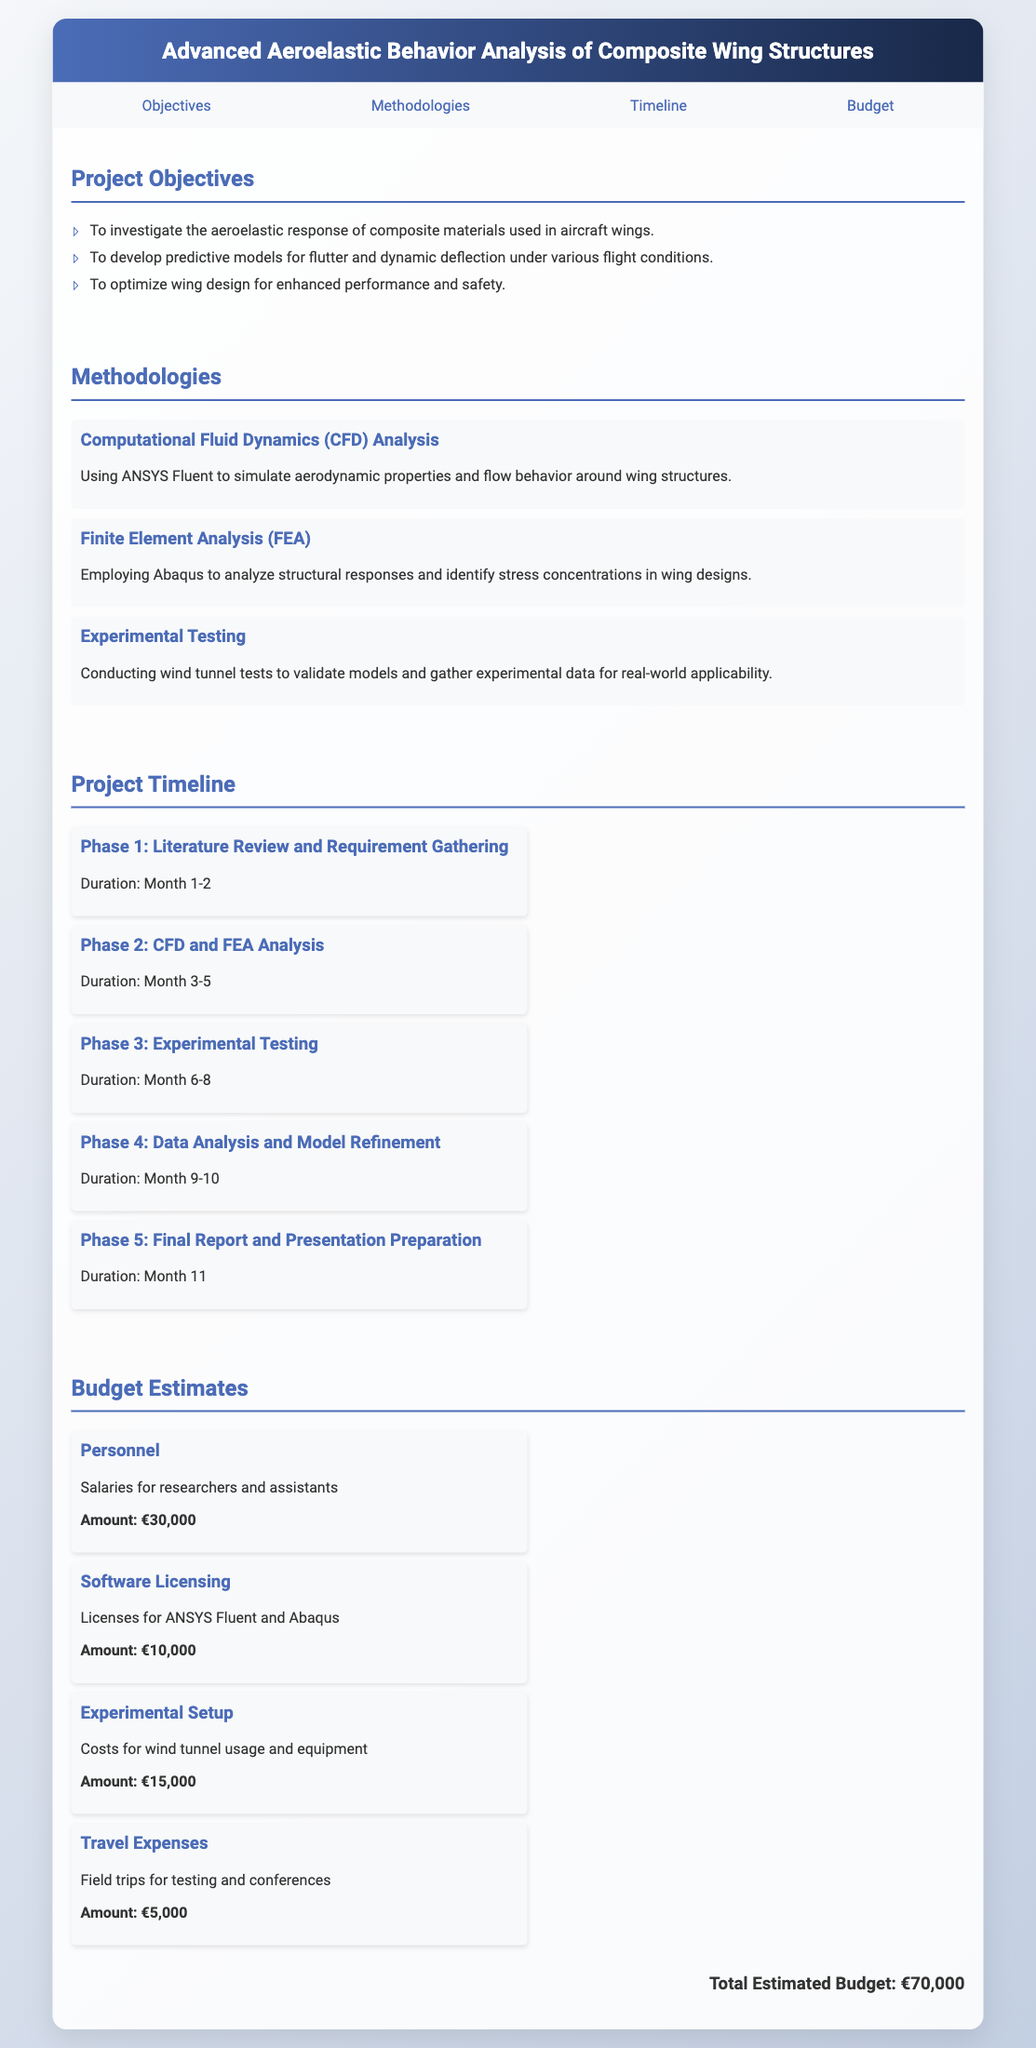What is the title of the project? The title is stated prominently in the document header.
Answer: Advanced Aeroelastic Behavior Analysis of Composite Wing Structures How many phases are in the project timeline? The timeline section lists five distinct phases of the project.
Answer: 5 What is the amount allocated for software licensing? This budget item is explicitly mentioned under the budget estimates section.
Answer: €10,000 What methodology involves using ANSYS Fluent? This methodology is detailed in the methodologies section, specifying its use for CFD analysis.
Answer: Computational Fluid Dynamics (CFD) Analysis What is the duration of the experimental testing phase? The duration for this phase is indicated in the timeline section.
Answer: Month 6-8 What is the total estimated budget for the project? The total is calculated based on the individual budget items listed in the document.
Answer: €70,000 Which phase includes data analysis and model refinement? This is specified in the timeline section, detailing the activities for that phase.
Answer: Phase 4 What type of testing is conducted to validate models? The document specifies this testing method in the methodologies section.
Answer: Experimental Testing Who are the targeted personnel for salary in the budget? The budget section mentions the researcher and assistants related to this expense.
Answer: Researchers and assistants 